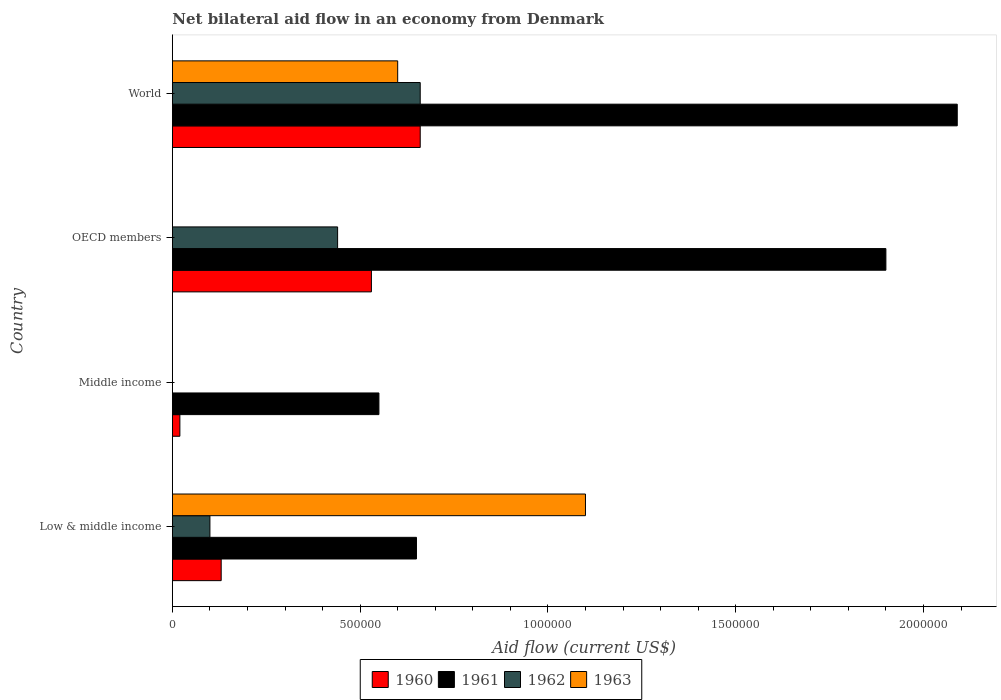How many different coloured bars are there?
Offer a terse response. 4. How many groups of bars are there?
Ensure brevity in your answer.  4. Are the number of bars per tick equal to the number of legend labels?
Your answer should be very brief. No. Are the number of bars on each tick of the Y-axis equal?
Provide a succinct answer. No. How many bars are there on the 3rd tick from the top?
Your answer should be compact. 2. What is the label of the 3rd group of bars from the top?
Provide a succinct answer. Middle income. What is the net bilateral aid flow in 1961 in Middle income?
Ensure brevity in your answer.  5.50e+05. Across all countries, what is the maximum net bilateral aid flow in 1962?
Offer a very short reply. 6.60e+05. Across all countries, what is the minimum net bilateral aid flow in 1960?
Keep it short and to the point. 2.00e+04. In which country was the net bilateral aid flow in 1961 maximum?
Give a very brief answer. World. What is the total net bilateral aid flow in 1961 in the graph?
Provide a short and direct response. 5.19e+06. What is the difference between the net bilateral aid flow in 1961 in Low & middle income and that in OECD members?
Offer a very short reply. -1.25e+06. What is the difference between the net bilateral aid flow in 1963 in Middle income and the net bilateral aid flow in 1961 in Low & middle income?
Keep it short and to the point. -6.50e+05. What is the average net bilateral aid flow in 1962 per country?
Your answer should be very brief. 3.00e+05. What is the difference between the net bilateral aid flow in 1961 and net bilateral aid flow in 1960 in OECD members?
Your answer should be very brief. 1.37e+06. What is the ratio of the net bilateral aid flow in 1960 in Low & middle income to that in World?
Your answer should be compact. 0.2. Is the net bilateral aid flow in 1963 in Low & middle income less than that in World?
Ensure brevity in your answer.  No. Is the difference between the net bilateral aid flow in 1961 in Middle income and OECD members greater than the difference between the net bilateral aid flow in 1960 in Middle income and OECD members?
Give a very brief answer. No. What is the difference between the highest and the lowest net bilateral aid flow in 1960?
Keep it short and to the point. 6.40e+05. Is it the case that in every country, the sum of the net bilateral aid flow in 1962 and net bilateral aid flow in 1961 is greater than the sum of net bilateral aid flow in 1960 and net bilateral aid flow in 1963?
Offer a terse response. No. How many bars are there?
Ensure brevity in your answer.  13. How many countries are there in the graph?
Keep it short and to the point. 4. Are the values on the major ticks of X-axis written in scientific E-notation?
Ensure brevity in your answer.  No. Does the graph contain any zero values?
Keep it short and to the point. Yes. Where does the legend appear in the graph?
Offer a terse response. Bottom center. What is the title of the graph?
Your answer should be very brief. Net bilateral aid flow in an economy from Denmark. What is the label or title of the Y-axis?
Keep it short and to the point. Country. What is the Aid flow (current US$) of 1961 in Low & middle income?
Keep it short and to the point. 6.50e+05. What is the Aid flow (current US$) in 1963 in Low & middle income?
Your answer should be compact. 1.10e+06. What is the Aid flow (current US$) in 1961 in Middle income?
Offer a very short reply. 5.50e+05. What is the Aid flow (current US$) of 1960 in OECD members?
Offer a terse response. 5.30e+05. What is the Aid flow (current US$) of 1961 in OECD members?
Provide a succinct answer. 1.90e+06. What is the Aid flow (current US$) in 1963 in OECD members?
Your response must be concise. 0. What is the Aid flow (current US$) of 1961 in World?
Your answer should be very brief. 2.09e+06. What is the Aid flow (current US$) in 1962 in World?
Offer a very short reply. 6.60e+05. What is the Aid flow (current US$) of 1963 in World?
Offer a terse response. 6.00e+05. Across all countries, what is the maximum Aid flow (current US$) of 1960?
Provide a short and direct response. 6.60e+05. Across all countries, what is the maximum Aid flow (current US$) in 1961?
Your answer should be very brief. 2.09e+06. Across all countries, what is the maximum Aid flow (current US$) of 1962?
Your answer should be very brief. 6.60e+05. Across all countries, what is the maximum Aid flow (current US$) of 1963?
Offer a very short reply. 1.10e+06. Across all countries, what is the minimum Aid flow (current US$) of 1960?
Make the answer very short. 2.00e+04. Across all countries, what is the minimum Aid flow (current US$) in 1961?
Give a very brief answer. 5.50e+05. Across all countries, what is the minimum Aid flow (current US$) in 1962?
Provide a short and direct response. 0. Across all countries, what is the minimum Aid flow (current US$) in 1963?
Give a very brief answer. 0. What is the total Aid flow (current US$) in 1960 in the graph?
Give a very brief answer. 1.34e+06. What is the total Aid flow (current US$) in 1961 in the graph?
Provide a short and direct response. 5.19e+06. What is the total Aid flow (current US$) of 1962 in the graph?
Your response must be concise. 1.20e+06. What is the total Aid flow (current US$) of 1963 in the graph?
Your response must be concise. 1.70e+06. What is the difference between the Aid flow (current US$) of 1960 in Low & middle income and that in Middle income?
Give a very brief answer. 1.10e+05. What is the difference between the Aid flow (current US$) in 1960 in Low & middle income and that in OECD members?
Your response must be concise. -4.00e+05. What is the difference between the Aid flow (current US$) in 1961 in Low & middle income and that in OECD members?
Make the answer very short. -1.25e+06. What is the difference between the Aid flow (current US$) in 1960 in Low & middle income and that in World?
Make the answer very short. -5.30e+05. What is the difference between the Aid flow (current US$) of 1961 in Low & middle income and that in World?
Provide a short and direct response. -1.44e+06. What is the difference between the Aid flow (current US$) of 1962 in Low & middle income and that in World?
Make the answer very short. -5.60e+05. What is the difference between the Aid flow (current US$) in 1960 in Middle income and that in OECD members?
Provide a succinct answer. -5.10e+05. What is the difference between the Aid flow (current US$) in 1961 in Middle income and that in OECD members?
Your answer should be compact. -1.35e+06. What is the difference between the Aid flow (current US$) of 1960 in Middle income and that in World?
Keep it short and to the point. -6.40e+05. What is the difference between the Aid flow (current US$) in 1961 in Middle income and that in World?
Give a very brief answer. -1.54e+06. What is the difference between the Aid flow (current US$) in 1960 in OECD members and that in World?
Provide a short and direct response. -1.30e+05. What is the difference between the Aid flow (current US$) of 1961 in OECD members and that in World?
Your answer should be very brief. -1.90e+05. What is the difference between the Aid flow (current US$) of 1962 in OECD members and that in World?
Make the answer very short. -2.20e+05. What is the difference between the Aid flow (current US$) of 1960 in Low & middle income and the Aid flow (current US$) of 1961 in Middle income?
Provide a succinct answer. -4.20e+05. What is the difference between the Aid flow (current US$) in 1960 in Low & middle income and the Aid flow (current US$) in 1961 in OECD members?
Keep it short and to the point. -1.77e+06. What is the difference between the Aid flow (current US$) of 1960 in Low & middle income and the Aid flow (current US$) of 1962 in OECD members?
Give a very brief answer. -3.10e+05. What is the difference between the Aid flow (current US$) of 1960 in Low & middle income and the Aid flow (current US$) of 1961 in World?
Provide a short and direct response. -1.96e+06. What is the difference between the Aid flow (current US$) of 1960 in Low & middle income and the Aid flow (current US$) of 1962 in World?
Your response must be concise. -5.30e+05. What is the difference between the Aid flow (current US$) of 1960 in Low & middle income and the Aid flow (current US$) of 1963 in World?
Provide a short and direct response. -4.70e+05. What is the difference between the Aid flow (current US$) of 1961 in Low & middle income and the Aid flow (current US$) of 1962 in World?
Keep it short and to the point. -10000. What is the difference between the Aid flow (current US$) in 1961 in Low & middle income and the Aid flow (current US$) in 1963 in World?
Keep it short and to the point. 5.00e+04. What is the difference between the Aid flow (current US$) of 1962 in Low & middle income and the Aid flow (current US$) of 1963 in World?
Give a very brief answer. -5.00e+05. What is the difference between the Aid flow (current US$) of 1960 in Middle income and the Aid flow (current US$) of 1961 in OECD members?
Give a very brief answer. -1.88e+06. What is the difference between the Aid flow (current US$) in 1960 in Middle income and the Aid flow (current US$) in 1962 in OECD members?
Your answer should be very brief. -4.20e+05. What is the difference between the Aid flow (current US$) of 1961 in Middle income and the Aid flow (current US$) of 1962 in OECD members?
Give a very brief answer. 1.10e+05. What is the difference between the Aid flow (current US$) of 1960 in Middle income and the Aid flow (current US$) of 1961 in World?
Keep it short and to the point. -2.07e+06. What is the difference between the Aid flow (current US$) of 1960 in Middle income and the Aid flow (current US$) of 1962 in World?
Make the answer very short. -6.40e+05. What is the difference between the Aid flow (current US$) in 1960 in Middle income and the Aid flow (current US$) in 1963 in World?
Make the answer very short. -5.80e+05. What is the difference between the Aid flow (current US$) in 1961 in Middle income and the Aid flow (current US$) in 1962 in World?
Offer a very short reply. -1.10e+05. What is the difference between the Aid flow (current US$) of 1960 in OECD members and the Aid flow (current US$) of 1961 in World?
Give a very brief answer. -1.56e+06. What is the difference between the Aid flow (current US$) in 1960 in OECD members and the Aid flow (current US$) in 1962 in World?
Provide a succinct answer. -1.30e+05. What is the difference between the Aid flow (current US$) in 1961 in OECD members and the Aid flow (current US$) in 1962 in World?
Give a very brief answer. 1.24e+06. What is the difference between the Aid flow (current US$) in 1961 in OECD members and the Aid flow (current US$) in 1963 in World?
Keep it short and to the point. 1.30e+06. What is the average Aid flow (current US$) in 1960 per country?
Provide a short and direct response. 3.35e+05. What is the average Aid flow (current US$) of 1961 per country?
Keep it short and to the point. 1.30e+06. What is the average Aid flow (current US$) in 1963 per country?
Give a very brief answer. 4.25e+05. What is the difference between the Aid flow (current US$) in 1960 and Aid flow (current US$) in 1961 in Low & middle income?
Provide a short and direct response. -5.20e+05. What is the difference between the Aid flow (current US$) in 1960 and Aid flow (current US$) in 1962 in Low & middle income?
Keep it short and to the point. 3.00e+04. What is the difference between the Aid flow (current US$) of 1960 and Aid flow (current US$) of 1963 in Low & middle income?
Ensure brevity in your answer.  -9.70e+05. What is the difference between the Aid flow (current US$) in 1961 and Aid flow (current US$) in 1962 in Low & middle income?
Make the answer very short. 5.50e+05. What is the difference between the Aid flow (current US$) of 1961 and Aid flow (current US$) of 1963 in Low & middle income?
Your answer should be compact. -4.50e+05. What is the difference between the Aid flow (current US$) of 1962 and Aid flow (current US$) of 1963 in Low & middle income?
Ensure brevity in your answer.  -1.00e+06. What is the difference between the Aid flow (current US$) of 1960 and Aid flow (current US$) of 1961 in Middle income?
Give a very brief answer. -5.30e+05. What is the difference between the Aid flow (current US$) of 1960 and Aid flow (current US$) of 1961 in OECD members?
Provide a short and direct response. -1.37e+06. What is the difference between the Aid flow (current US$) of 1961 and Aid flow (current US$) of 1962 in OECD members?
Offer a terse response. 1.46e+06. What is the difference between the Aid flow (current US$) of 1960 and Aid flow (current US$) of 1961 in World?
Your response must be concise. -1.43e+06. What is the difference between the Aid flow (current US$) of 1960 and Aid flow (current US$) of 1963 in World?
Ensure brevity in your answer.  6.00e+04. What is the difference between the Aid flow (current US$) of 1961 and Aid flow (current US$) of 1962 in World?
Offer a terse response. 1.43e+06. What is the difference between the Aid flow (current US$) of 1961 and Aid flow (current US$) of 1963 in World?
Make the answer very short. 1.49e+06. What is the ratio of the Aid flow (current US$) of 1961 in Low & middle income to that in Middle income?
Give a very brief answer. 1.18. What is the ratio of the Aid flow (current US$) of 1960 in Low & middle income to that in OECD members?
Offer a very short reply. 0.25. What is the ratio of the Aid flow (current US$) of 1961 in Low & middle income to that in OECD members?
Ensure brevity in your answer.  0.34. What is the ratio of the Aid flow (current US$) of 1962 in Low & middle income to that in OECD members?
Provide a short and direct response. 0.23. What is the ratio of the Aid flow (current US$) in 1960 in Low & middle income to that in World?
Keep it short and to the point. 0.2. What is the ratio of the Aid flow (current US$) in 1961 in Low & middle income to that in World?
Keep it short and to the point. 0.31. What is the ratio of the Aid flow (current US$) in 1962 in Low & middle income to that in World?
Make the answer very short. 0.15. What is the ratio of the Aid flow (current US$) of 1963 in Low & middle income to that in World?
Provide a short and direct response. 1.83. What is the ratio of the Aid flow (current US$) in 1960 in Middle income to that in OECD members?
Make the answer very short. 0.04. What is the ratio of the Aid flow (current US$) of 1961 in Middle income to that in OECD members?
Your answer should be compact. 0.29. What is the ratio of the Aid flow (current US$) in 1960 in Middle income to that in World?
Provide a short and direct response. 0.03. What is the ratio of the Aid flow (current US$) in 1961 in Middle income to that in World?
Your answer should be very brief. 0.26. What is the ratio of the Aid flow (current US$) in 1960 in OECD members to that in World?
Provide a short and direct response. 0.8. What is the difference between the highest and the lowest Aid flow (current US$) in 1960?
Ensure brevity in your answer.  6.40e+05. What is the difference between the highest and the lowest Aid flow (current US$) in 1961?
Make the answer very short. 1.54e+06. What is the difference between the highest and the lowest Aid flow (current US$) of 1962?
Your answer should be very brief. 6.60e+05. What is the difference between the highest and the lowest Aid flow (current US$) in 1963?
Offer a very short reply. 1.10e+06. 